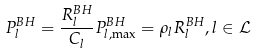Convert formula to latex. <formula><loc_0><loc_0><loc_500><loc_500>P _ { l } ^ { B H } = \frac { R _ { l } ^ { B H } } { C _ { l } } P _ { l , \max } ^ { B H } = \rho _ { l } R _ { l } ^ { B H } , l \in \mathcal { L }</formula> 